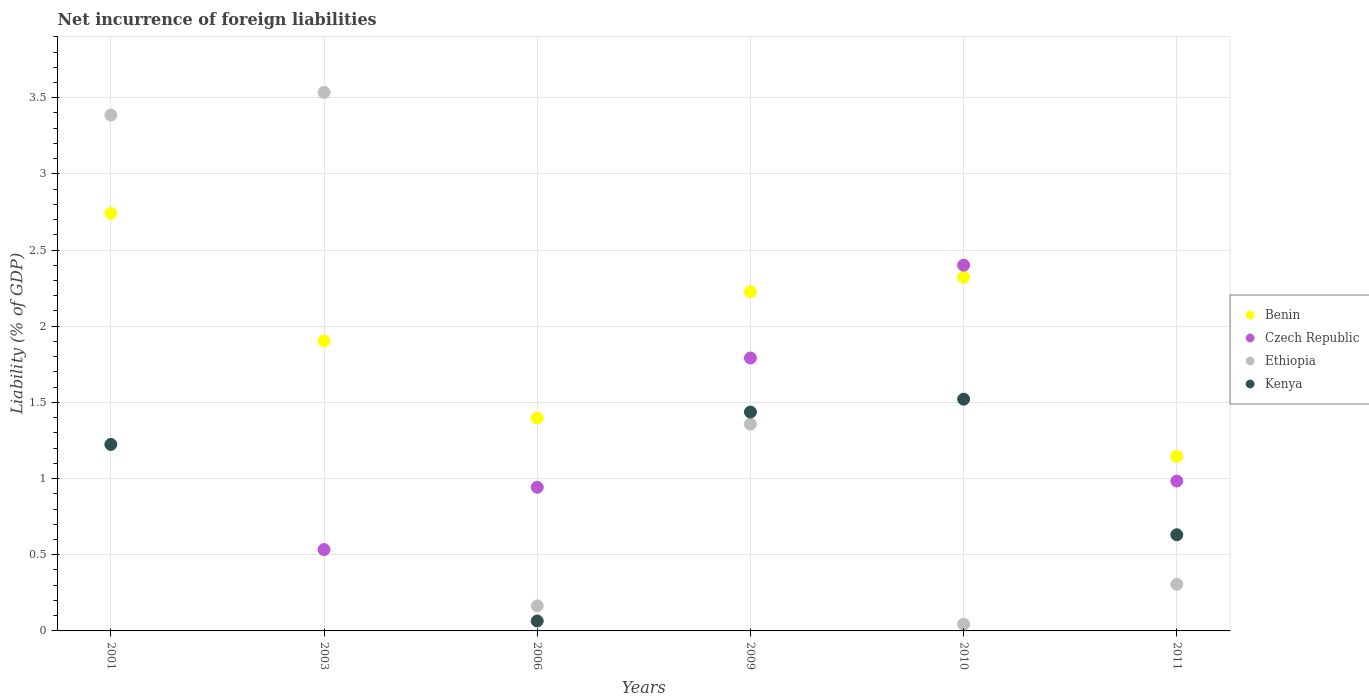Is the number of dotlines equal to the number of legend labels?
Offer a very short reply. No. What is the net incurrence of foreign liabilities in Benin in 2009?
Give a very brief answer. 2.23. Across all years, what is the maximum net incurrence of foreign liabilities in Czech Republic?
Offer a terse response. 2.4. In which year was the net incurrence of foreign liabilities in Ethiopia maximum?
Ensure brevity in your answer.  2003. What is the total net incurrence of foreign liabilities in Kenya in the graph?
Ensure brevity in your answer.  4.88. What is the difference between the net incurrence of foreign liabilities in Ethiopia in 2006 and that in 2011?
Offer a very short reply. -0.14. What is the difference between the net incurrence of foreign liabilities in Benin in 2006 and the net incurrence of foreign liabilities in Ethiopia in 2011?
Keep it short and to the point. 1.09. What is the average net incurrence of foreign liabilities in Czech Republic per year?
Ensure brevity in your answer.  1.11. In the year 2006, what is the difference between the net incurrence of foreign liabilities in Benin and net incurrence of foreign liabilities in Kenya?
Provide a short and direct response. 1.33. What is the ratio of the net incurrence of foreign liabilities in Czech Republic in 2003 to that in 2011?
Offer a very short reply. 0.54. Is the net incurrence of foreign liabilities in Ethiopia in 2001 less than that in 2011?
Make the answer very short. No. Is the difference between the net incurrence of foreign liabilities in Benin in 2006 and 2010 greater than the difference between the net incurrence of foreign liabilities in Kenya in 2006 and 2010?
Make the answer very short. Yes. What is the difference between the highest and the second highest net incurrence of foreign liabilities in Czech Republic?
Provide a succinct answer. 0.61. What is the difference between the highest and the lowest net incurrence of foreign liabilities in Czech Republic?
Give a very brief answer. 2.4. Is the sum of the net incurrence of foreign liabilities in Benin in 2001 and 2006 greater than the maximum net incurrence of foreign liabilities in Kenya across all years?
Offer a terse response. Yes. Does the net incurrence of foreign liabilities in Kenya monotonically increase over the years?
Make the answer very short. No. How many years are there in the graph?
Your answer should be compact. 6. Are the values on the major ticks of Y-axis written in scientific E-notation?
Offer a very short reply. No. Does the graph contain any zero values?
Offer a very short reply. Yes. Where does the legend appear in the graph?
Provide a succinct answer. Center right. What is the title of the graph?
Ensure brevity in your answer.  Net incurrence of foreign liabilities. Does "Mexico" appear as one of the legend labels in the graph?
Provide a succinct answer. No. What is the label or title of the Y-axis?
Offer a terse response. Liability (% of GDP). What is the Liability (% of GDP) in Benin in 2001?
Offer a terse response. 2.74. What is the Liability (% of GDP) in Ethiopia in 2001?
Offer a very short reply. 3.39. What is the Liability (% of GDP) in Kenya in 2001?
Offer a very short reply. 1.22. What is the Liability (% of GDP) in Benin in 2003?
Your answer should be compact. 1.9. What is the Liability (% of GDP) in Czech Republic in 2003?
Your answer should be compact. 0.53. What is the Liability (% of GDP) in Ethiopia in 2003?
Your answer should be compact. 3.53. What is the Liability (% of GDP) in Benin in 2006?
Give a very brief answer. 1.4. What is the Liability (% of GDP) of Czech Republic in 2006?
Make the answer very short. 0.94. What is the Liability (% of GDP) in Ethiopia in 2006?
Provide a succinct answer. 0.16. What is the Liability (% of GDP) in Kenya in 2006?
Provide a succinct answer. 0.07. What is the Liability (% of GDP) in Benin in 2009?
Your answer should be compact. 2.23. What is the Liability (% of GDP) in Czech Republic in 2009?
Offer a terse response. 1.79. What is the Liability (% of GDP) in Ethiopia in 2009?
Your response must be concise. 1.36. What is the Liability (% of GDP) of Kenya in 2009?
Make the answer very short. 1.44. What is the Liability (% of GDP) of Benin in 2010?
Give a very brief answer. 2.32. What is the Liability (% of GDP) of Czech Republic in 2010?
Your response must be concise. 2.4. What is the Liability (% of GDP) of Ethiopia in 2010?
Give a very brief answer. 0.04. What is the Liability (% of GDP) in Kenya in 2010?
Your answer should be very brief. 1.52. What is the Liability (% of GDP) of Benin in 2011?
Your answer should be very brief. 1.15. What is the Liability (% of GDP) in Czech Republic in 2011?
Keep it short and to the point. 0.98. What is the Liability (% of GDP) of Ethiopia in 2011?
Keep it short and to the point. 0.31. What is the Liability (% of GDP) in Kenya in 2011?
Offer a very short reply. 0.63. Across all years, what is the maximum Liability (% of GDP) in Benin?
Ensure brevity in your answer.  2.74. Across all years, what is the maximum Liability (% of GDP) of Czech Republic?
Your response must be concise. 2.4. Across all years, what is the maximum Liability (% of GDP) of Ethiopia?
Give a very brief answer. 3.53. Across all years, what is the maximum Liability (% of GDP) in Kenya?
Provide a succinct answer. 1.52. Across all years, what is the minimum Liability (% of GDP) in Benin?
Ensure brevity in your answer.  1.15. Across all years, what is the minimum Liability (% of GDP) in Ethiopia?
Make the answer very short. 0.04. Across all years, what is the minimum Liability (% of GDP) of Kenya?
Provide a short and direct response. 0. What is the total Liability (% of GDP) of Benin in the graph?
Provide a short and direct response. 11.74. What is the total Liability (% of GDP) of Czech Republic in the graph?
Your answer should be very brief. 6.65. What is the total Liability (% of GDP) in Ethiopia in the graph?
Provide a succinct answer. 8.79. What is the total Liability (% of GDP) of Kenya in the graph?
Keep it short and to the point. 4.88. What is the difference between the Liability (% of GDP) of Benin in 2001 and that in 2003?
Give a very brief answer. 0.84. What is the difference between the Liability (% of GDP) of Ethiopia in 2001 and that in 2003?
Your response must be concise. -0.15. What is the difference between the Liability (% of GDP) in Benin in 2001 and that in 2006?
Provide a succinct answer. 1.34. What is the difference between the Liability (% of GDP) in Ethiopia in 2001 and that in 2006?
Your answer should be compact. 3.22. What is the difference between the Liability (% of GDP) of Kenya in 2001 and that in 2006?
Your response must be concise. 1.16. What is the difference between the Liability (% of GDP) in Benin in 2001 and that in 2009?
Provide a succinct answer. 0.51. What is the difference between the Liability (% of GDP) in Ethiopia in 2001 and that in 2009?
Your answer should be very brief. 2.03. What is the difference between the Liability (% of GDP) of Kenya in 2001 and that in 2009?
Your answer should be very brief. -0.21. What is the difference between the Liability (% of GDP) in Benin in 2001 and that in 2010?
Make the answer very short. 0.42. What is the difference between the Liability (% of GDP) in Ethiopia in 2001 and that in 2010?
Offer a very short reply. 3.34. What is the difference between the Liability (% of GDP) of Kenya in 2001 and that in 2010?
Your response must be concise. -0.3. What is the difference between the Liability (% of GDP) in Benin in 2001 and that in 2011?
Keep it short and to the point. 1.59. What is the difference between the Liability (% of GDP) of Ethiopia in 2001 and that in 2011?
Make the answer very short. 3.08. What is the difference between the Liability (% of GDP) of Kenya in 2001 and that in 2011?
Keep it short and to the point. 0.59. What is the difference between the Liability (% of GDP) in Benin in 2003 and that in 2006?
Your answer should be very brief. 0.5. What is the difference between the Liability (% of GDP) of Czech Republic in 2003 and that in 2006?
Give a very brief answer. -0.41. What is the difference between the Liability (% of GDP) of Ethiopia in 2003 and that in 2006?
Provide a short and direct response. 3.37. What is the difference between the Liability (% of GDP) in Benin in 2003 and that in 2009?
Ensure brevity in your answer.  -0.32. What is the difference between the Liability (% of GDP) in Czech Republic in 2003 and that in 2009?
Provide a short and direct response. -1.26. What is the difference between the Liability (% of GDP) of Ethiopia in 2003 and that in 2009?
Offer a terse response. 2.18. What is the difference between the Liability (% of GDP) of Benin in 2003 and that in 2010?
Your answer should be very brief. -0.42. What is the difference between the Liability (% of GDP) of Czech Republic in 2003 and that in 2010?
Offer a very short reply. -1.87. What is the difference between the Liability (% of GDP) of Ethiopia in 2003 and that in 2010?
Provide a short and direct response. 3.49. What is the difference between the Liability (% of GDP) in Benin in 2003 and that in 2011?
Your response must be concise. 0.76. What is the difference between the Liability (% of GDP) in Czech Republic in 2003 and that in 2011?
Offer a very short reply. -0.45. What is the difference between the Liability (% of GDP) of Ethiopia in 2003 and that in 2011?
Offer a very short reply. 3.23. What is the difference between the Liability (% of GDP) in Benin in 2006 and that in 2009?
Ensure brevity in your answer.  -0.83. What is the difference between the Liability (% of GDP) in Czech Republic in 2006 and that in 2009?
Offer a very short reply. -0.85. What is the difference between the Liability (% of GDP) of Ethiopia in 2006 and that in 2009?
Make the answer very short. -1.19. What is the difference between the Liability (% of GDP) of Kenya in 2006 and that in 2009?
Your response must be concise. -1.37. What is the difference between the Liability (% of GDP) of Benin in 2006 and that in 2010?
Ensure brevity in your answer.  -0.92. What is the difference between the Liability (% of GDP) of Czech Republic in 2006 and that in 2010?
Offer a terse response. -1.46. What is the difference between the Liability (% of GDP) of Ethiopia in 2006 and that in 2010?
Provide a succinct answer. 0.12. What is the difference between the Liability (% of GDP) of Kenya in 2006 and that in 2010?
Provide a succinct answer. -1.46. What is the difference between the Liability (% of GDP) in Benin in 2006 and that in 2011?
Offer a very short reply. 0.25. What is the difference between the Liability (% of GDP) of Czech Republic in 2006 and that in 2011?
Make the answer very short. -0.04. What is the difference between the Liability (% of GDP) in Ethiopia in 2006 and that in 2011?
Your answer should be very brief. -0.14. What is the difference between the Liability (% of GDP) in Kenya in 2006 and that in 2011?
Ensure brevity in your answer.  -0.57. What is the difference between the Liability (% of GDP) in Benin in 2009 and that in 2010?
Offer a terse response. -0.09. What is the difference between the Liability (% of GDP) in Czech Republic in 2009 and that in 2010?
Make the answer very short. -0.61. What is the difference between the Liability (% of GDP) of Ethiopia in 2009 and that in 2010?
Your response must be concise. 1.31. What is the difference between the Liability (% of GDP) of Kenya in 2009 and that in 2010?
Provide a succinct answer. -0.08. What is the difference between the Liability (% of GDP) of Benin in 2009 and that in 2011?
Make the answer very short. 1.08. What is the difference between the Liability (% of GDP) of Czech Republic in 2009 and that in 2011?
Your answer should be compact. 0.81. What is the difference between the Liability (% of GDP) in Ethiopia in 2009 and that in 2011?
Give a very brief answer. 1.05. What is the difference between the Liability (% of GDP) of Kenya in 2009 and that in 2011?
Ensure brevity in your answer.  0.81. What is the difference between the Liability (% of GDP) of Benin in 2010 and that in 2011?
Provide a succinct answer. 1.18. What is the difference between the Liability (% of GDP) of Czech Republic in 2010 and that in 2011?
Make the answer very short. 1.42. What is the difference between the Liability (% of GDP) in Ethiopia in 2010 and that in 2011?
Your response must be concise. -0.26. What is the difference between the Liability (% of GDP) of Kenya in 2010 and that in 2011?
Your answer should be very brief. 0.89. What is the difference between the Liability (% of GDP) of Benin in 2001 and the Liability (% of GDP) of Czech Republic in 2003?
Your answer should be compact. 2.21. What is the difference between the Liability (% of GDP) of Benin in 2001 and the Liability (% of GDP) of Ethiopia in 2003?
Your response must be concise. -0.79. What is the difference between the Liability (% of GDP) in Benin in 2001 and the Liability (% of GDP) in Czech Republic in 2006?
Make the answer very short. 1.8. What is the difference between the Liability (% of GDP) in Benin in 2001 and the Liability (% of GDP) in Ethiopia in 2006?
Your response must be concise. 2.58. What is the difference between the Liability (% of GDP) in Benin in 2001 and the Liability (% of GDP) in Kenya in 2006?
Ensure brevity in your answer.  2.68. What is the difference between the Liability (% of GDP) in Ethiopia in 2001 and the Liability (% of GDP) in Kenya in 2006?
Your response must be concise. 3.32. What is the difference between the Liability (% of GDP) in Benin in 2001 and the Liability (% of GDP) in Czech Republic in 2009?
Offer a terse response. 0.95. What is the difference between the Liability (% of GDP) in Benin in 2001 and the Liability (% of GDP) in Ethiopia in 2009?
Your answer should be compact. 1.38. What is the difference between the Liability (% of GDP) of Benin in 2001 and the Liability (% of GDP) of Kenya in 2009?
Provide a succinct answer. 1.3. What is the difference between the Liability (% of GDP) of Ethiopia in 2001 and the Liability (% of GDP) of Kenya in 2009?
Provide a succinct answer. 1.95. What is the difference between the Liability (% of GDP) in Benin in 2001 and the Liability (% of GDP) in Czech Republic in 2010?
Offer a very short reply. 0.34. What is the difference between the Liability (% of GDP) of Benin in 2001 and the Liability (% of GDP) of Ethiopia in 2010?
Keep it short and to the point. 2.7. What is the difference between the Liability (% of GDP) of Benin in 2001 and the Liability (% of GDP) of Kenya in 2010?
Your response must be concise. 1.22. What is the difference between the Liability (% of GDP) in Ethiopia in 2001 and the Liability (% of GDP) in Kenya in 2010?
Make the answer very short. 1.87. What is the difference between the Liability (% of GDP) of Benin in 2001 and the Liability (% of GDP) of Czech Republic in 2011?
Your response must be concise. 1.76. What is the difference between the Liability (% of GDP) of Benin in 2001 and the Liability (% of GDP) of Ethiopia in 2011?
Provide a short and direct response. 2.43. What is the difference between the Liability (% of GDP) of Benin in 2001 and the Liability (% of GDP) of Kenya in 2011?
Provide a succinct answer. 2.11. What is the difference between the Liability (% of GDP) in Ethiopia in 2001 and the Liability (% of GDP) in Kenya in 2011?
Provide a short and direct response. 2.75. What is the difference between the Liability (% of GDP) of Benin in 2003 and the Liability (% of GDP) of Czech Republic in 2006?
Your answer should be very brief. 0.96. What is the difference between the Liability (% of GDP) of Benin in 2003 and the Liability (% of GDP) of Ethiopia in 2006?
Provide a succinct answer. 1.74. What is the difference between the Liability (% of GDP) in Benin in 2003 and the Liability (% of GDP) in Kenya in 2006?
Your answer should be compact. 1.84. What is the difference between the Liability (% of GDP) in Czech Republic in 2003 and the Liability (% of GDP) in Ethiopia in 2006?
Your answer should be very brief. 0.37. What is the difference between the Liability (% of GDP) in Czech Republic in 2003 and the Liability (% of GDP) in Kenya in 2006?
Provide a succinct answer. 0.47. What is the difference between the Liability (% of GDP) of Ethiopia in 2003 and the Liability (% of GDP) of Kenya in 2006?
Provide a short and direct response. 3.47. What is the difference between the Liability (% of GDP) of Benin in 2003 and the Liability (% of GDP) of Czech Republic in 2009?
Offer a very short reply. 0.11. What is the difference between the Liability (% of GDP) in Benin in 2003 and the Liability (% of GDP) in Ethiopia in 2009?
Your response must be concise. 0.55. What is the difference between the Liability (% of GDP) in Benin in 2003 and the Liability (% of GDP) in Kenya in 2009?
Provide a succinct answer. 0.47. What is the difference between the Liability (% of GDP) in Czech Republic in 2003 and the Liability (% of GDP) in Ethiopia in 2009?
Provide a short and direct response. -0.82. What is the difference between the Liability (% of GDP) of Czech Republic in 2003 and the Liability (% of GDP) of Kenya in 2009?
Your answer should be very brief. -0.9. What is the difference between the Liability (% of GDP) in Ethiopia in 2003 and the Liability (% of GDP) in Kenya in 2009?
Provide a succinct answer. 2.1. What is the difference between the Liability (% of GDP) in Benin in 2003 and the Liability (% of GDP) in Czech Republic in 2010?
Offer a very short reply. -0.5. What is the difference between the Liability (% of GDP) of Benin in 2003 and the Liability (% of GDP) of Ethiopia in 2010?
Give a very brief answer. 1.86. What is the difference between the Liability (% of GDP) of Benin in 2003 and the Liability (% of GDP) of Kenya in 2010?
Provide a succinct answer. 0.38. What is the difference between the Liability (% of GDP) in Czech Republic in 2003 and the Liability (% of GDP) in Ethiopia in 2010?
Your answer should be very brief. 0.49. What is the difference between the Liability (% of GDP) in Czech Republic in 2003 and the Liability (% of GDP) in Kenya in 2010?
Your response must be concise. -0.99. What is the difference between the Liability (% of GDP) in Ethiopia in 2003 and the Liability (% of GDP) in Kenya in 2010?
Give a very brief answer. 2.01. What is the difference between the Liability (% of GDP) in Benin in 2003 and the Liability (% of GDP) in Czech Republic in 2011?
Offer a very short reply. 0.92. What is the difference between the Liability (% of GDP) of Benin in 2003 and the Liability (% of GDP) of Ethiopia in 2011?
Provide a succinct answer. 1.6. What is the difference between the Liability (% of GDP) in Benin in 2003 and the Liability (% of GDP) in Kenya in 2011?
Offer a terse response. 1.27. What is the difference between the Liability (% of GDP) of Czech Republic in 2003 and the Liability (% of GDP) of Ethiopia in 2011?
Your answer should be compact. 0.23. What is the difference between the Liability (% of GDP) of Czech Republic in 2003 and the Liability (% of GDP) of Kenya in 2011?
Provide a succinct answer. -0.1. What is the difference between the Liability (% of GDP) in Ethiopia in 2003 and the Liability (% of GDP) in Kenya in 2011?
Your answer should be very brief. 2.9. What is the difference between the Liability (% of GDP) in Benin in 2006 and the Liability (% of GDP) in Czech Republic in 2009?
Your response must be concise. -0.39. What is the difference between the Liability (% of GDP) of Benin in 2006 and the Liability (% of GDP) of Ethiopia in 2009?
Keep it short and to the point. 0.04. What is the difference between the Liability (% of GDP) in Benin in 2006 and the Liability (% of GDP) in Kenya in 2009?
Offer a very short reply. -0.04. What is the difference between the Liability (% of GDP) of Czech Republic in 2006 and the Liability (% of GDP) of Ethiopia in 2009?
Offer a terse response. -0.41. What is the difference between the Liability (% of GDP) of Czech Republic in 2006 and the Liability (% of GDP) of Kenya in 2009?
Give a very brief answer. -0.49. What is the difference between the Liability (% of GDP) of Ethiopia in 2006 and the Liability (% of GDP) of Kenya in 2009?
Provide a short and direct response. -1.27. What is the difference between the Liability (% of GDP) of Benin in 2006 and the Liability (% of GDP) of Czech Republic in 2010?
Provide a succinct answer. -1. What is the difference between the Liability (% of GDP) in Benin in 2006 and the Liability (% of GDP) in Ethiopia in 2010?
Your answer should be compact. 1.35. What is the difference between the Liability (% of GDP) of Benin in 2006 and the Liability (% of GDP) of Kenya in 2010?
Your response must be concise. -0.12. What is the difference between the Liability (% of GDP) in Czech Republic in 2006 and the Liability (% of GDP) in Ethiopia in 2010?
Provide a short and direct response. 0.9. What is the difference between the Liability (% of GDP) of Czech Republic in 2006 and the Liability (% of GDP) of Kenya in 2010?
Make the answer very short. -0.58. What is the difference between the Liability (% of GDP) in Ethiopia in 2006 and the Liability (% of GDP) in Kenya in 2010?
Make the answer very short. -1.36. What is the difference between the Liability (% of GDP) of Benin in 2006 and the Liability (% of GDP) of Czech Republic in 2011?
Your answer should be compact. 0.41. What is the difference between the Liability (% of GDP) of Benin in 2006 and the Liability (% of GDP) of Ethiopia in 2011?
Provide a short and direct response. 1.09. What is the difference between the Liability (% of GDP) in Benin in 2006 and the Liability (% of GDP) in Kenya in 2011?
Provide a succinct answer. 0.77. What is the difference between the Liability (% of GDP) in Czech Republic in 2006 and the Liability (% of GDP) in Ethiopia in 2011?
Provide a succinct answer. 0.64. What is the difference between the Liability (% of GDP) of Czech Republic in 2006 and the Liability (% of GDP) of Kenya in 2011?
Provide a succinct answer. 0.31. What is the difference between the Liability (% of GDP) of Ethiopia in 2006 and the Liability (% of GDP) of Kenya in 2011?
Your response must be concise. -0.47. What is the difference between the Liability (% of GDP) of Benin in 2009 and the Liability (% of GDP) of Czech Republic in 2010?
Ensure brevity in your answer.  -0.17. What is the difference between the Liability (% of GDP) of Benin in 2009 and the Liability (% of GDP) of Ethiopia in 2010?
Offer a terse response. 2.18. What is the difference between the Liability (% of GDP) of Benin in 2009 and the Liability (% of GDP) of Kenya in 2010?
Provide a short and direct response. 0.71. What is the difference between the Liability (% of GDP) of Czech Republic in 2009 and the Liability (% of GDP) of Ethiopia in 2010?
Your answer should be very brief. 1.75. What is the difference between the Liability (% of GDP) of Czech Republic in 2009 and the Liability (% of GDP) of Kenya in 2010?
Ensure brevity in your answer.  0.27. What is the difference between the Liability (% of GDP) in Ethiopia in 2009 and the Liability (% of GDP) in Kenya in 2010?
Offer a very short reply. -0.16. What is the difference between the Liability (% of GDP) of Benin in 2009 and the Liability (% of GDP) of Czech Republic in 2011?
Offer a terse response. 1.24. What is the difference between the Liability (% of GDP) of Benin in 2009 and the Liability (% of GDP) of Ethiopia in 2011?
Ensure brevity in your answer.  1.92. What is the difference between the Liability (% of GDP) in Benin in 2009 and the Liability (% of GDP) in Kenya in 2011?
Provide a succinct answer. 1.6. What is the difference between the Liability (% of GDP) in Czech Republic in 2009 and the Liability (% of GDP) in Ethiopia in 2011?
Make the answer very short. 1.49. What is the difference between the Liability (% of GDP) in Czech Republic in 2009 and the Liability (% of GDP) in Kenya in 2011?
Ensure brevity in your answer.  1.16. What is the difference between the Liability (% of GDP) in Ethiopia in 2009 and the Liability (% of GDP) in Kenya in 2011?
Provide a succinct answer. 0.73. What is the difference between the Liability (% of GDP) of Benin in 2010 and the Liability (% of GDP) of Czech Republic in 2011?
Your answer should be compact. 1.34. What is the difference between the Liability (% of GDP) of Benin in 2010 and the Liability (% of GDP) of Ethiopia in 2011?
Keep it short and to the point. 2.02. What is the difference between the Liability (% of GDP) of Benin in 2010 and the Liability (% of GDP) of Kenya in 2011?
Keep it short and to the point. 1.69. What is the difference between the Liability (% of GDP) of Czech Republic in 2010 and the Liability (% of GDP) of Ethiopia in 2011?
Your answer should be very brief. 2.1. What is the difference between the Liability (% of GDP) of Czech Republic in 2010 and the Liability (% of GDP) of Kenya in 2011?
Offer a very short reply. 1.77. What is the difference between the Liability (% of GDP) in Ethiopia in 2010 and the Liability (% of GDP) in Kenya in 2011?
Provide a short and direct response. -0.59. What is the average Liability (% of GDP) in Benin per year?
Make the answer very short. 1.96. What is the average Liability (% of GDP) in Czech Republic per year?
Offer a very short reply. 1.11. What is the average Liability (% of GDP) of Ethiopia per year?
Provide a short and direct response. 1.47. What is the average Liability (% of GDP) in Kenya per year?
Keep it short and to the point. 0.81. In the year 2001, what is the difference between the Liability (% of GDP) of Benin and Liability (% of GDP) of Ethiopia?
Offer a very short reply. -0.65. In the year 2001, what is the difference between the Liability (% of GDP) of Benin and Liability (% of GDP) of Kenya?
Your answer should be compact. 1.52. In the year 2001, what is the difference between the Liability (% of GDP) in Ethiopia and Liability (% of GDP) in Kenya?
Offer a terse response. 2.16. In the year 2003, what is the difference between the Liability (% of GDP) in Benin and Liability (% of GDP) in Czech Republic?
Make the answer very short. 1.37. In the year 2003, what is the difference between the Liability (% of GDP) in Benin and Liability (% of GDP) in Ethiopia?
Make the answer very short. -1.63. In the year 2003, what is the difference between the Liability (% of GDP) in Czech Republic and Liability (% of GDP) in Ethiopia?
Offer a terse response. -3. In the year 2006, what is the difference between the Liability (% of GDP) of Benin and Liability (% of GDP) of Czech Republic?
Keep it short and to the point. 0.46. In the year 2006, what is the difference between the Liability (% of GDP) in Benin and Liability (% of GDP) in Ethiopia?
Provide a succinct answer. 1.23. In the year 2006, what is the difference between the Liability (% of GDP) of Benin and Liability (% of GDP) of Kenya?
Your answer should be compact. 1.33. In the year 2006, what is the difference between the Liability (% of GDP) of Czech Republic and Liability (% of GDP) of Ethiopia?
Keep it short and to the point. 0.78. In the year 2006, what is the difference between the Liability (% of GDP) of Czech Republic and Liability (% of GDP) of Kenya?
Offer a very short reply. 0.88. In the year 2006, what is the difference between the Liability (% of GDP) of Ethiopia and Liability (% of GDP) of Kenya?
Give a very brief answer. 0.1. In the year 2009, what is the difference between the Liability (% of GDP) of Benin and Liability (% of GDP) of Czech Republic?
Provide a succinct answer. 0.44. In the year 2009, what is the difference between the Liability (% of GDP) in Benin and Liability (% of GDP) in Ethiopia?
Offer a terse response. 0.87. In the year 2009, what is the difference between the Liability (% of GDP) in Benin and Liability (% of GDP) in Kenya?
Ensure brevity in your answer.  0.79. In the year 2009, what is the difference between the Liability (% of GDP) in Czech Republic and Liability (% of GDP) in Ethiopia?
Provide a short and direct response. 0.43. In the year 2009, what is the difference between the Liability (% of GDP) in Czech Republic and Liability (% of GDP) in Kenya?
Provide a succinct answer. 0.35. In the year 2009, what is the difference between the Liability (% of GDP) of Ethiopia and Liability (% of GDP) of Kenya?
Provide a succinct answer. -0.08. In the year 2010, what is the difference between the Liability (% of GDP) in Benin and Liability (% of GDP) in Czech Republic?
Your answer should be very brief. -0.08. In the year 2010, what is the difference between the Liability (% of GDP) in Benin and Liability (% of GDP) in Ethiopia?
Your response must be concise. 2.28. In the year 2010, what is the difference between the Liability (% of GDP) of Benin and Liability (% of GDP) of Kenya?
Your answer should be compact. 0.8. In the year 2010, what is the difference between the Liability (% of GDP) of Czech Republic and Liability (% of GDP) of Ethiopia?
Offer a terse response. 2.36. In the year 2010, what is the difference between the Liability (% of GDP) in Czech Republic and Liability (% of GDP) in Kenya?
Provide a short and direct response. 0.88. In the year 2010, what is the difference between the Liability (% of GDP) in Ethiopia and Liability (% of GDP) in Kenya?
Your response must be concise. -1.48. In the year 2011, what is the difference between the Liability (% of GDP) in Benin and Liability (% of GDP) in Czech Republic?
Provide a succinct answer. 0.16. In the year 2011, what is the difference between the Liability (% of GDP) of Benin and Liability (% of GDP) of Ethiopia?
Offer a terse response. 0.84. In the year 2011, what is the difference between the Liability (% of GDP) of Benin and Liability (% of GDP) of Kenya?
Offer a very short reply. 0.51. In the year 2011, what is the difference between the Liability (% of GDP) of Czech Republic and Liability (% of GDP) of Ethiopia?
Your answer should be compact. 0.68. In the year 2011, what is the difference between the Liability (% of GDP) of Czech Republic and Liability (% of GDP) of Kenya?
Keep it short and to the point. 0.35. In the year 2011, what is the difference between the Liability (% of GDP) of Ethiopia and Liability (% of GDP) of Kenya?
Offer a very short reply. -0.33. What is the ratio of the Liability (% of GDP) of Benin in 2001 to that in 2003?
Make the answer very short. 1.44. What is the ratio of the Liability (% of GDP) in Ethiopia in 2001 to that in 2003?
Keep it short and to the point. 0.96. What is the ratio of the Liability (% of GDP) of Benin in 2001 to that in 2006?
Your answer should be very brief. 1.96. What is the ratio of the Liability (% of GDP) of Ethiopia in 2001 to that in 2006?
Your response must be concise. 20.57. What is the ratio of the Liability (% of GDP) in Kenya in 2001 to that in 2006?
Offer a very short reply. 18.75. What is the ratio of the Liability (% of GDP) in Benin in 2001 to that in 2009?
Provide a succinct answer. 1.23. What is the ratio of the Liability (% of GDP) of Ethiopia in 2001 to that in 2009?
Your answer should be very brief. 2.5. What is the ratio of the Liability (% of GDP) in Kenya in 2001 to that in 2009?
Give a very brief answer. 0.85. What is the ratio of the Liability (% of GDP) of Benin in 2001 to that in 2010?
Provide a succinct answer. 1.18. What is the ratio of the Liability (% of GDP) of Ethiopia in 2001 to that in 2010?
Your answer should be compact. 76.73. What is the ratio of the Liability (% of GDP) of Kenya in 2001 to that in 2010?
Your response must be concise. 0.8. What is the ratio of the Liability (% of GDP) in Benin in 2001 to that in 2011?
Your answer should be compact. 2.39. What is the ratio of the Liability (% of GDP) in Ethiopia in 2001 to that in 2011?
Provide a succinct answer. 11.07. What is the ratio of the Liability (% of GDP) of Kenya in 2001 to that in 2011?
Make the answer very short. 1.94. What is the ratio of the Liability (% of GDP) in Benin in 2003 to that in 2006?
Offer a terse response. 1.36. What is the ratio of the Liability (% of GDP) in Czech Republic in 2003 to that in 2006?
Provide a short and direct response. 0.57. What is the ratio of the Liability (% of GDP) of Ethiopia in 2003 to that in 2006?
Your response must be concise. 21.47. What is the ratio of the Liability (% of GDP) in Benin in 2003 to that in 2009?
Make the answer very short. 0.85. What is the ratio of the Liability (% of GDP) in Czech Republic in 2003 to that in 2009?
Your response must be concise. 0.3. What is the ratio of the Liability (% of GDP) in Ethiopia in 2003 to that in 2009?
Your answer should be very brief. 2.6. What is the ratio of the Liability (% of GDP) of Benin in 2003 to that in 2010?
Offer a very short reply. 0.82. What is the ratio of the Liability (% of GDP) in Czech Republic in 2003 to that in 2010?
Your answer should be compact. 0.22. What is the ratio of the Liability (% of GDP) of Ethiopia in 2003 to that in 2010?
Your answer should be compact. 80.1. What is the ratio of the Liability (% of GDP) in Benin in 2003 to that in 2011?
Ensure brevity in your answer.  1.66. What is the ratio of the Liability (% of GDP) in Czech Republic in 2003 to that in 2011?
Your answer should be compact. 0.54. What is the ratio of the Liability (% of GDP) of Ethiopia in 2003 to that in 2011?
Offer a terse response. 11.56. What is the ratio of the Liability (% of GDP) of Benin in 2006 to that in 2009?
Offer a very short reply. 0.63. What is the ratio of the Liability (% of GDP) of Czech Republic in 2006 to that in 2009?
Offer a terse response. 0.53. What is the ratio of the Liability (% of GDP) of Ethiopia in 2006 to that in 2009?
Give a very brief answer. 0.12. What is the ratio of the Liability (% of GDP) of Kenya in 2006 to that in 2009?
Offer a terse response. 0.05. What is the ratio of the Liability (% of GDP) of Benin in 2006 to that in 2010?
Keep it short and to the point. 0.6. What is the ratio of the Liability (% of GDP) of Czech Republic in 2006 to that in 2010?
Your answer should be very brief. 0.39. What is the ratio of the Liability (% of GDP) of Ethiopia in 2006 to that in 2010?
Your answer should be compact. 3.73. What is the ratio of the Liability (% of GDP) in Kenya in 2006 to that in 2010?
Your response must be concise. 0.04. What is the ratio of the Liability (% of GDP) of Benin in 2006 to that in 2011?
Your answer should be compact. 1.22. What is the ratio of the Liability (% of GDP) in Czech Republic in 2006 to that in 2011?
Your answer should be compact. 0.96. What is the ratio of the Liability (% of GDP) in Ethiopia in 2006 to that in 2011?
Make the answer very short. 0.54. What is the ratio of the Liability (% of GDP) in Kenya in 2006 to that in 2011?
Your answer should be very brief. 0.1. What is the ratio of the Liability (% of GDP) of Benin in 2009 to that in 2010?
Provide a succinct answer. 0.96. What is the ratio of the Liability (% of GDP) of Czech Republic in 2009 to that in 2010?
Provide a short and direct response. 0.75. What is the ratio of the Liability (% of GDP) of Ethiopia in 2009 to that in 2010?
Make the answer very short. 30.75. What is the ratio of the Liability (% of GDP) of Kenya in 2009 to that in 2010?
Ensure brevity in your answer.  0.94. What is the ratio of the Liability (% of GDP) of Benin in 2009 to that in 2011?
Ensure brevity in your answer.  1.94. What is the ratio of the Liability (% of GDP) in Czech Republic in 2009 to that in 2011?
Your response must be concise. 1.82. What is the ratio of the Liability (% of GDP) of Ethiopia in 2009 to that in 2011?
Your answer should be compact. 4.44. What is the ratio of the Liability (% of GDP) in Kenya in 2009 to that in 2011?
Ensure brevity in your answer.  2.28. What is the ratio of the Liability (% of GDP) in Benin in 2010 to that in 2011?
Make the answer very short. 2.03. What is the ratio of the Liability (% of GDP) in Czech Republic in 2010 to that in 2011?
Offer a terse response. 2.44. What is the ratio of the Liability (% of GDP) of Ethiopia in 2010 to that in 2011?
Provide a short and direct response. 0.14. What is the ratio of the Liability (% of GDP) in Kenya in 2010 to that in 2011?
Your response must be concise. 2.41. What is the difference between the highest and the second highest Liability (% of GDP) of Benin?
Offer a terse response. 0.42. What is the difference between the highest and the second highest Liability (% of GDP) of Czech Republic?
Your answer should be very brief. 0.61. What is the difference between the highest and the second highest Liability (% of GDP) in Ethiopia?
Provide a succinct answer. 0.15. What is the difference between the highest and the second highest Liability (% of GDP) of Kenya?
Give a very brief answer. 0.08. What is the difference between the highest and the lowest Liability (% of GDP) in Benin?
Your response must be concise. 1.59. What is the difference between the highest and the lowest Liability (% of GDP) of Czech Republic?
Your answer should be compact. 2.4. What is the difference between the highest and the lowest Liability (% of GDP) in Ethiopia?
Ensure brevity in your answer.  3.49. What is the difference between the highest and the lowest Liability (% of GDP) of Kenya?
Offer a very short reply. 1.52. 